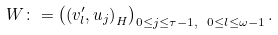Convert formula to latex. <formula><loc_0><loc_0><loc_500><loc_500>W \colon = \left ( \left ( v _ { l } ^ { \prime } , u _ { j } \right ) _ { H } \right ) _ { 0 \leq j \leq \tau - 1 , \ 0 \leq l \leq \omega - 1 } .</formula> 